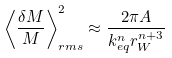<formula> <loc_0><loc_0><loc_500><loc_500>\left < \frac { \delta M } { M } \right > _ { r m s } ^ { 2 } \approx \frac { 2 \pi A } { k _ { e q } ^ { n } r _ { W } ^ { n + 3 } }</formula> 